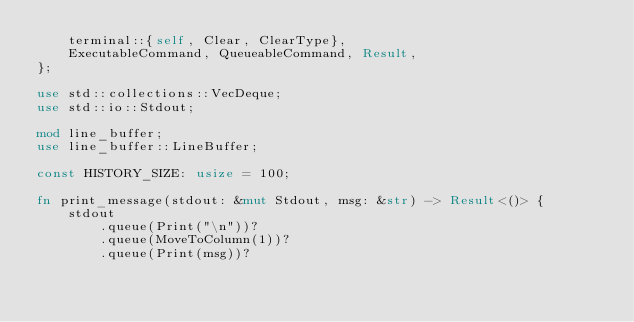<code> <loc_0><loc_0><loc_500><loc_500><_Rust_>    terminal::{self, Clear, ClearType},
    ExecutableCommand, QueueableCommand, Result,
};

use std::collections::VecDeque;
use std::io::Stdout;

mod line_buffer;
use line_buffer::LineBuffer;

const HISTORY_SIZE: usize = 100;

fn print_message(stdout: &mut Stdout, msg: &str) -> Result<()> {
    stdout
        .queue(Print("\n"))?
        .queue(MoveToColumn(1))?
        .queue(Print(msg))?</code> 